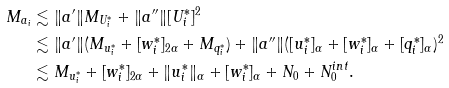<formula> <loc_0><loc_0><loc_500><loc_500>M _ { a _ { i } } & \lesssim \| a ^ { \prime } \| M _ { U _ { i } ^ { * } } + \| a ^ { \prime \prime } \| [ U _ { i } ^ { * } ] ^ { 2 } \\ & \lesssim \| a ^ { \prime } \| ( M _ { u _ { i } ^ { * } } + [ w _ { i } ^ { * } ] _ { 2 \alpha } + M _ { q ^ { * } _ { i } } ) + \| a ^ { \prime \prime } \| ( [ u ^ { * } _ { i } ] _ { \alpha } + [ w _ { i } ^ { * } ] _ { \alpha } + [ q ^ { * } _ { i } ] _ { \alpha } ) ^ { 2 } \\ & \lesssim M _ { u _ { i } ^ { * } } + [ w _ { i } ^ { * } ] _ { 2 \alpha } + \| u _ { i } ^ { * } \| _ { \alpha } + [ w _ { i } ^ { * } ] _ { \alpha } + N _ { 0 } + N _ { 0 } ^ { i n t } .</formula> 